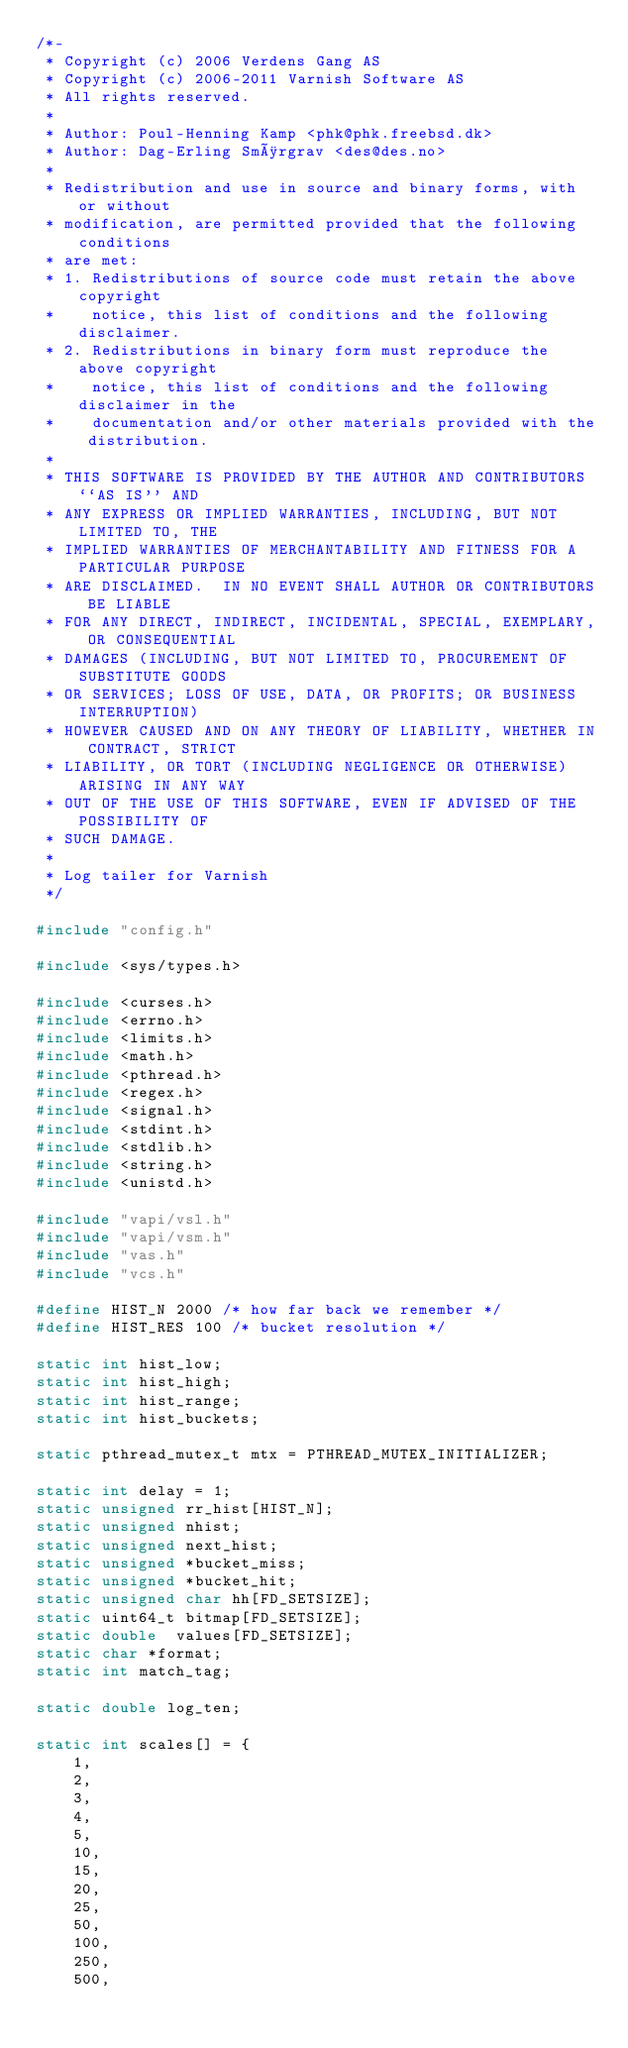Convert code to text. <code><loc_0><loc_0><loc_500><loc_500><_C_>/*-
 * Copyright (c) 2006 Verdens Gang AS
 * Copyright (c) 2006-2011 Varnish Software AS
 * All rights reserved.
 *
 * Author: Poul-Henning Kamp <phk@phk.freebsd.dk>
 * Author: Dag-Erling Smørgrav <des@des.no>
 *
 * Redistribution and use in source and binary forms, with or without
 * modification, are permitted provided that the following conditions
 * are met:
 * 1. Redistributions of source code must retain the above copyright
 *    notice, this list of conditions and the following disclaimer.
 * 2. Redistributions in binary form must reproduce the above copyright
 *    notice, this list of conditions and the following disclaimer in the
 *    documentation and/or other materials provided with the distribution.
 *
 * THIS SOFTWARE IS PROVIDED BY THE AUTHOR AND CONTRIBUTORS ``AS IS'' AND
 * ANY EXPRESS OR IMPLIED WARRANTIES, INCLUDING, BUT NOT LIMITED TO, THE
 * IMPLIED WARRANTIES OF MERCHANTABILITY AND FITNESS FOR A PARTICULAR PURPOSE
 * ARE DISCLAIMED.  IN NO EVENT SHALL AUTHOR OR CONTRIBUTORS BE LIABLE
 * FOR ANY DIRECT, INDIRECT, INCIDENTAL, SPECIAL, EXEMPLARY, OR CONSEQUENTIAL
 * DAMAGES (INCLUDING, BUT NOT LIMITED TO, PROCUREMENT OF SUBSTITUTE GOODS
 * OR SERVICES; LOSS OF USE, DATA, OR PROFITS; OR BUSINESS INTERRUPTION)
 * HOWEVER CAUSED AND ON ANY THEORY OF LIABILITY, WHETHER IN CONTRACT, STRICT
 * LIABILITY, OR TORT (INCLUDING NEGLIGENCE OR OTHERWISE) ARISING IN ANY WAY
 * OUT OF THE USE OF THIS SOFTWARE, EVEN IF ADVISED OF THE POSSIBILITY OF
 * SUCH DAMAGE.
 *
 * Log tailer for Varnish
 */

#include "config.h"

#include <sys/types.h>

#include <curses.h>
#include <errno.h>
#include <limits.h>
#include <math.h>
#include <pthread.h>
#include <regex.h>
#include <signal.h>
#include <stdint.h>
#include <stdlib.h>
#include <string.h>
#include <unistd.h>

#include "vapi/vsl.h"
#include "vapi/vsm.h"
#include "vas.h"
#include "vcs.h"

#define HIST_N 2000 /* how far back we remember */
#define HIST_RES 100 /* bucket resolution */

static int hist_low;
static int hist_high;
static int hist_range;
static int hist_buckets;

static pthread_mutex_t mtx = PTHREAD_MUTEX_INITIALIZER;

static int delay = 1;
static unsigned rr_hist[HIST_N];
static unsigned nhist;
static unsigned next_hist;
static unsigned *bucket_miss;
static unsigned *bucket_hit;
static unsigned char hh[FD_SETSIZE];
static uint64_t bitmap[FD_SETSIZE];
static double  values[FD_SETSIZE];
static char *format;
static int match_tag;

static double log_ten;

static int scales[] = {
	1,
	2,
	3,
	4,
	5,
	10,
	15,
	20,
	25,
	50,
	100,
	250,
	500,</code> 